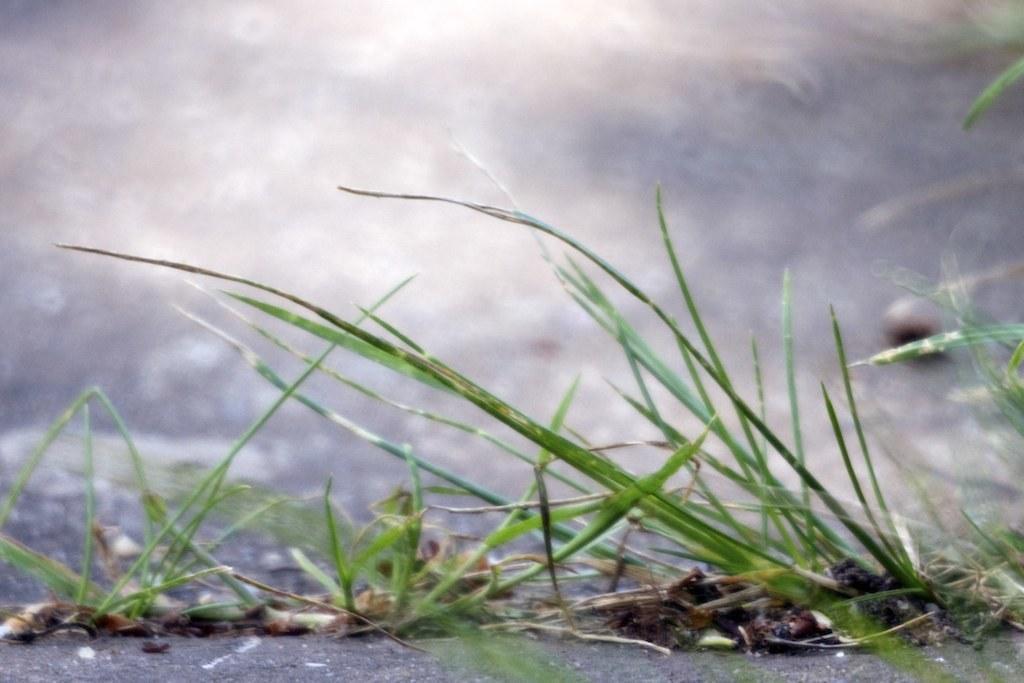Can you describe this image briefly? Here in this picture we can see grass present on the ground over there. 